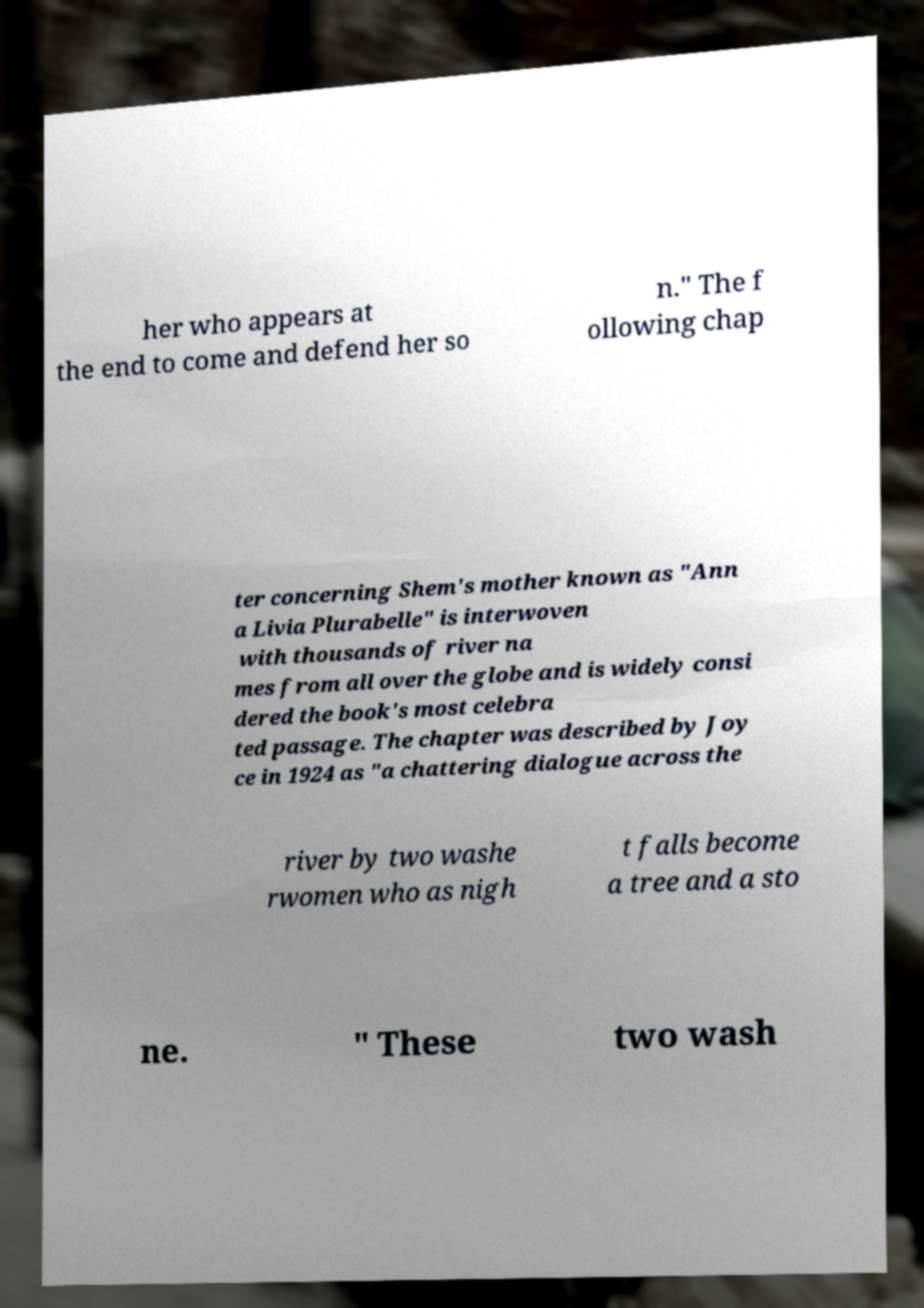Please read and relay the text visible in this image. What does it say? her who appears at the end to come and defend her so n." The f ollowing chap ter concerning Shem's mother known as "Ann a Livia Plurabelle" is interwoven with thousands of river na mes from all over the globe and is widely consi dered the book's most celebra ted passage. The chapter was described by Joy ce in 1924 as "a chattering dialogue across the river by two washe rwomen who as nigh t falls become a tree and a sto ne. " These two wash 